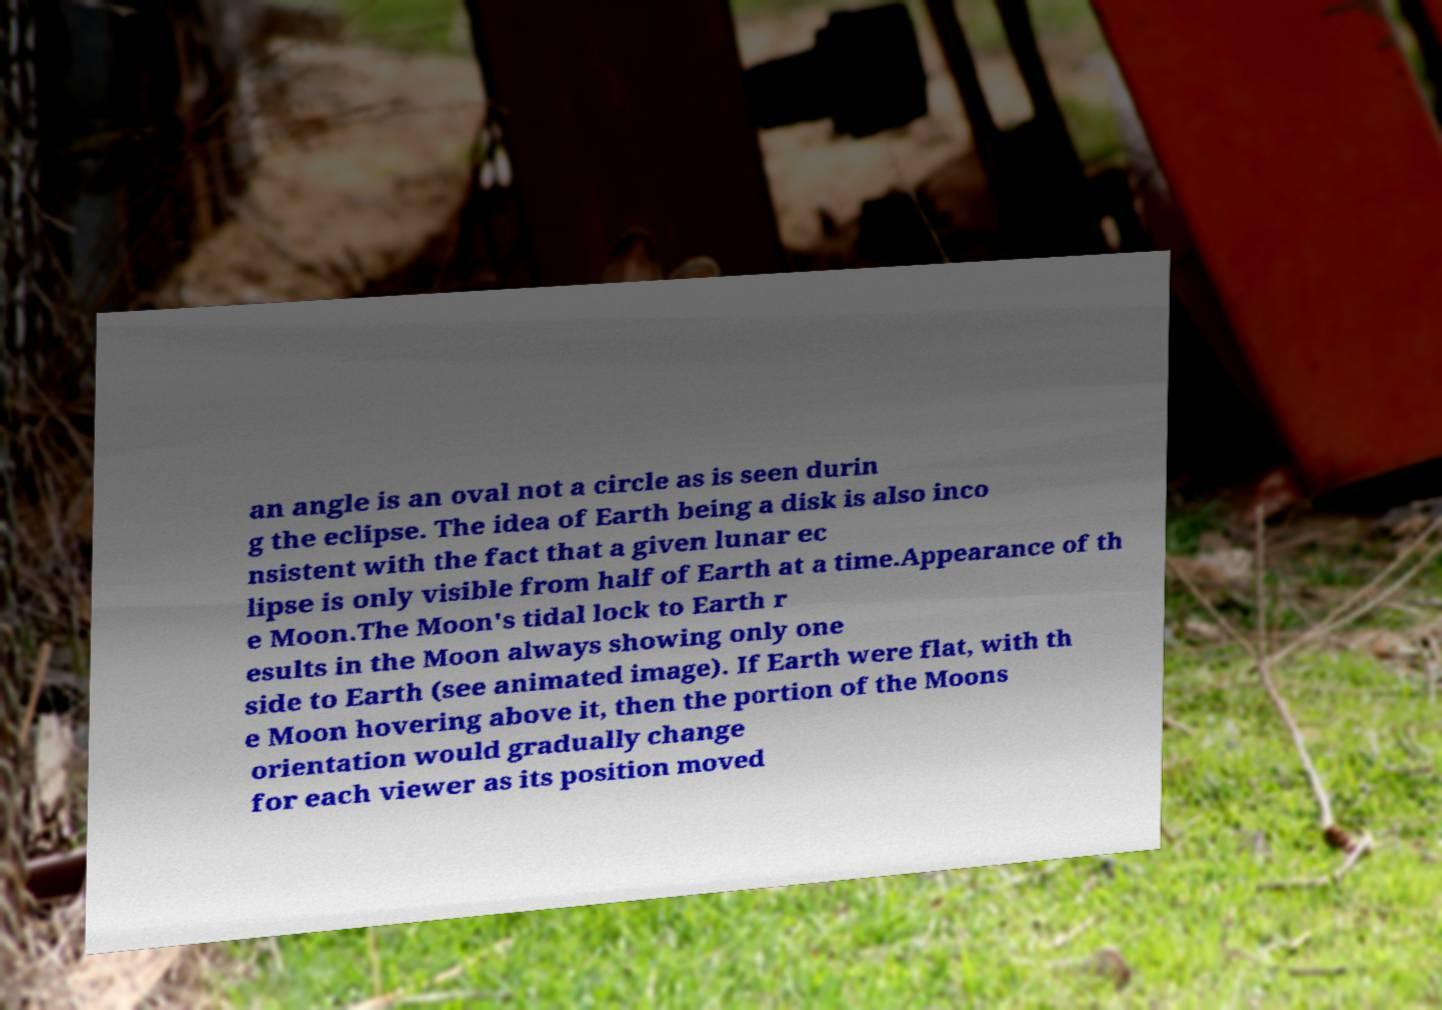Could you assist in decoding the text presented in this image and type it out clearly? an angle is an oval not a circle as is seen durin g the eclipse. The idea of Earth being a disk is also inco nsistent with the fact that a given lunar ec lipse is only visible from half of Earth at a time.Appearance of th e Moon.The Moon's tidal lock to Earth r esults in the Moon always showing only one side to Earth (see animated image). If Earth were flat, with th e Moon hovering above it, then the portion of the Moons orientation would gradually change for each viewer as its position moved 